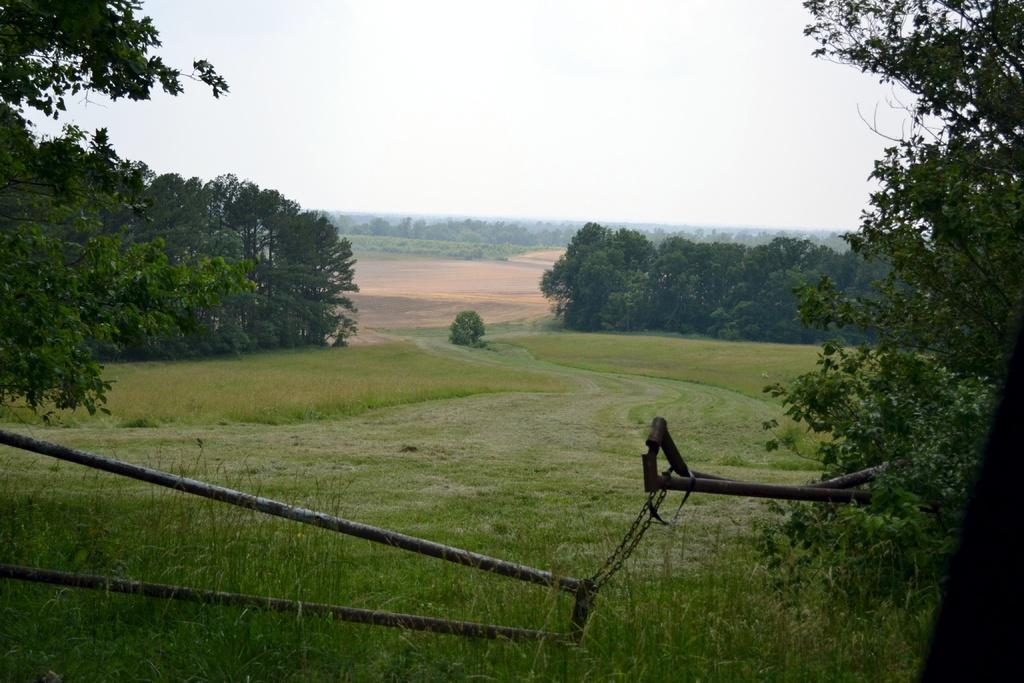What type of vegetation is present in the image? There are trees with branches and leaves in the image. What else can be seen on the ground in the image? There is grass in the image. Can you describe the iron object in the image? Yes, there appears to be an iron object in the image. What is visible in the background of the image? The sky is visible in the image. How many women are holding cakes in the image? There are no women or cakes present in the image. What type of neck is visible on the trees in the image? Trees do not have necks; the question is not applicable to the image. 